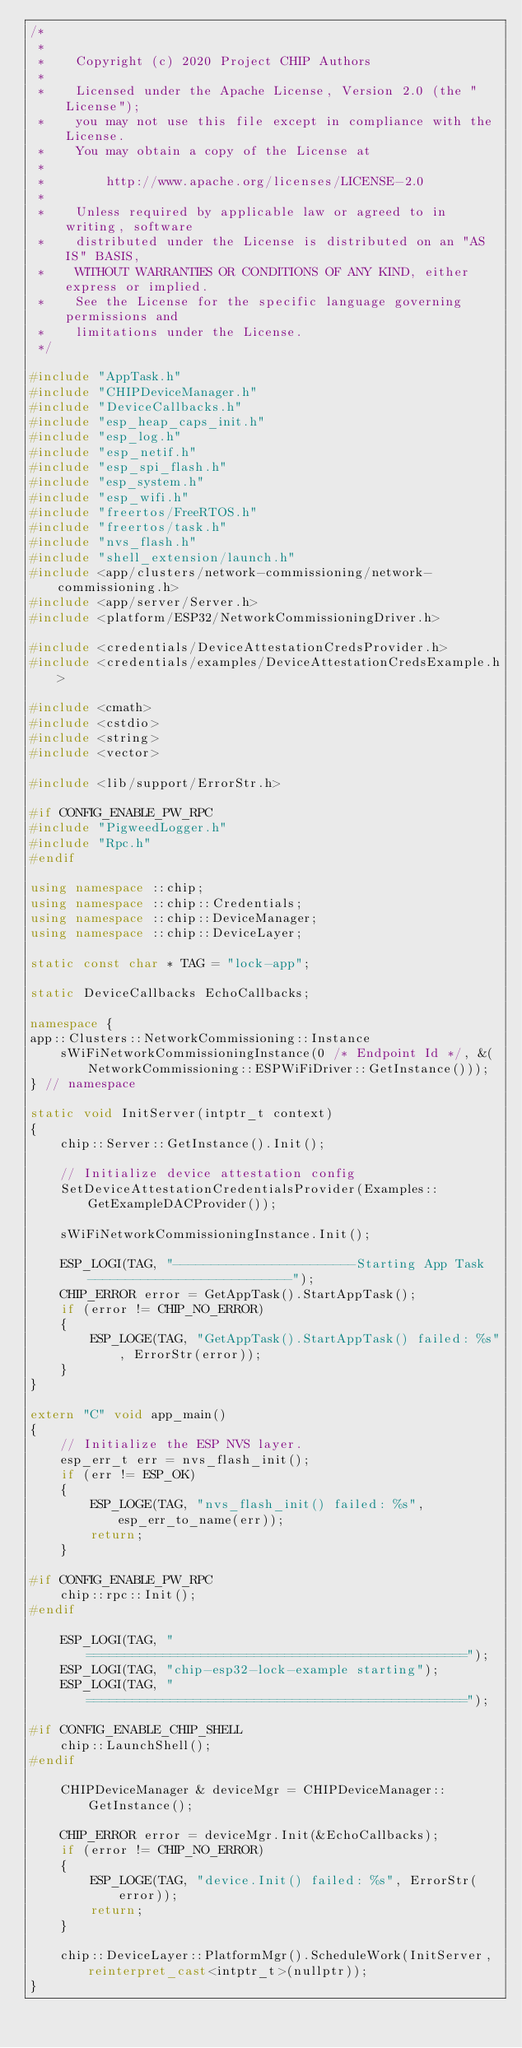<code> <loc_0><loc_0><loc_500><loc_500><_C++_>/*
 *
 *    Copyright (c) 2020 Project CHIP Authors
 *
 *    Licensed under the Apache License, Version 2.0 (the "License");
 *    you may not use this file except in compliance with the License.
 *    You may obtain a copy of the License at
 *
 *        http://www.apache.org/licenses/LICENSE-2.0
 *
 *    Unless required by applicable law or agreed to in writing, software
 *    distributed under the License is distributed on an "AS IS" BASIS,
 *    WITHOUT WARRANTIES OR CONDITIONS OF ANY KIND, either express or implied.
 *    See the License for the specific language governing permissions and
 *    limitations under the License.
 */

#include "AppTask.h"
#include "CHIPDeviceManager.h"
#include "DeviceCallbacks.h"
#include "esp_heap_caps_init.h"
#include "esp_log.h"
#include "esp_netif.h"
#include "esp_spi_flash.h"
#include "esp_system.h"
#include "esp_wifi.h"
#include "freertos/FreeRTOS.h"
#include "freertos/task.h"
#include "nvs_flash.h"
#include "shell_extension/launch.h"
#include <app/clusters/network-commissioning/network-commissioning.h>
#include <app/server/Server.h>
#include <platform/ESP32/NetworkCommissioningDriver.h>

#include <credentials/DeviceAttestationCredsProvider.h>
#include <credentials/examples/DeviceAttestationCredsExample.h>

#include <cmath>
#include <cstdio>
#include <string>
#include <vector>

#include <lib/support/ErrorStr.h>

#if CONFIG_ENABLE_PW_RPC
#include "PigweedLogger.h"
#include "Rpc.h"
#endif

using namespace ::chip;
using namespace ::chip::Credentials;
using namespace ::chip::DeviceManager;
using namespace ::chip::DeviceLayer;

static const char * TAG = "lock-app";

static DeviceCallbacks EchoCallbacks;

namespace {
app::Clusters::NetworkCommissioning::Instance
    sWiFiNetworkCommissioningInstance(0 /* Endpoint Id */, &(NetworkCommissioning::ESPWiFiDriver::GetInstance()));
} // namespace

static void InitServer(intptr_t context)
{
    chip::Server::GetInstance().Init();

    // Initialize device attestation config
    SetDeviceAttestationCredentialsProvider(Examples::GetExampleDACProvider());

    sWiFiNetworkCommissioningInstance.Init();

    ESP_LOGI(TAG, "------------------------Starting App Task---------------------------");
    CHIP_ERROR error = GetAppTask().StartAppTask();
    if (error != CHIP_NO_ERROR)
    {
        ESP_LOGE(TAG, "GetAppTask().StartAppTask() failed: %s", ErrorStr(error));
    }
}

extern "C" void app_main()
{
    // Initialize the ESP NVS layer.
    esp_err_t err = nvs_flash_init();
    if (err != ESP_OK)
    {
        ESP_LOGE(TAG, "nvs_flash_init() failed: %s", esp_err_to_name(err));
        return;
    }

#if CONFIG_ENABLE_PW_RPC
    chip::rpc::Init();
#endif

    ESP_LOGI(TAG, "==================================================");
    ESP_LOGI(TAG, "chip-esp32-lock-example starting");
    ESP_LOGI(TAG, "==================================================");

#if CONFIG_ENABLE_CHIP_SHELL
    chip::LaunchShell();
#endif

    CHIPDeviceManager & deviceMgr = CHIPDeviceManager::GetInstance();

    CHIP_ERROR error = deviceMgr.Init(&EchoCallbacks);
    if (error != CHIP_NO_ERROR)
    {
        ESP_LOGE(TAG, "device.Init() failed: %s", ErrorStr(error));
        return;
    }

    chip::DeviceLayer::PlatformMgr().ScheduleWork(InitServer, reinterpret_cast<intptr_t>(nullptr));
}
</code> 